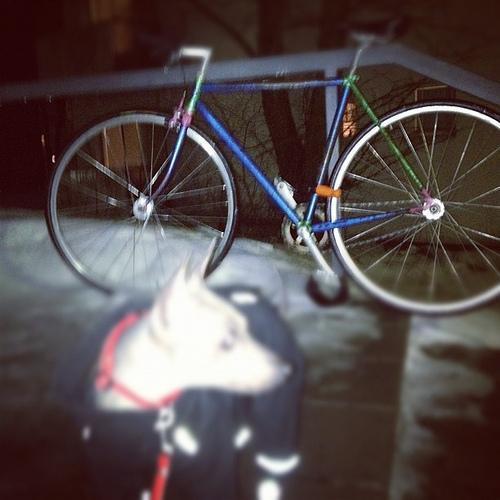How many dogs are there?
Give a very brief answer. 1. 